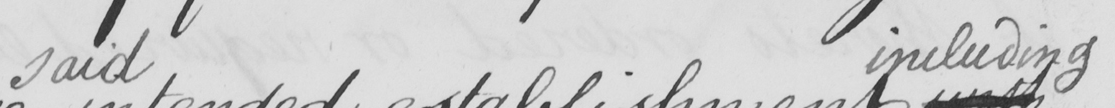What does this handwritten line say? said including 